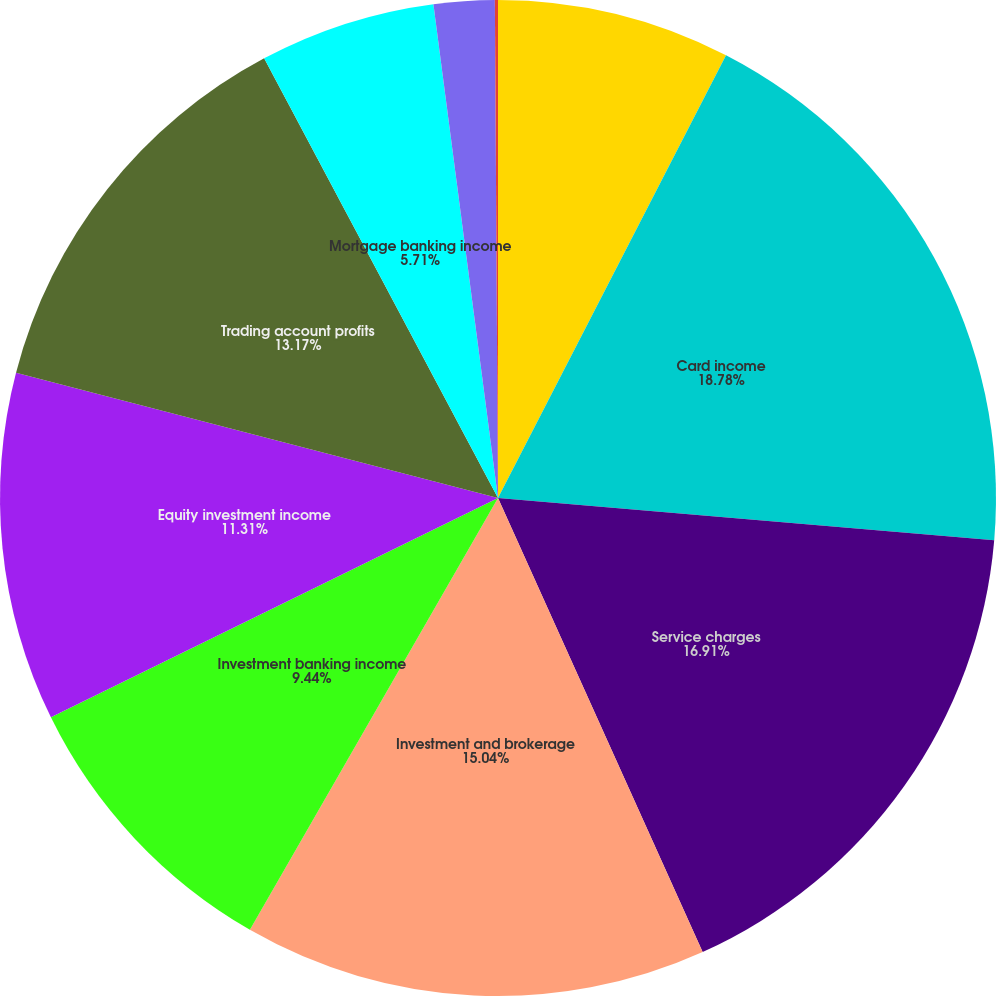Convert chart to OTSL. <chart><loc_0><loc_0><loc_500><loc_500><pie_chart><fcel>(Dollars in millions)<fcel>Card income<fcel>Service charges<fcel>Investment and brokerage<fcel>Investment banking income<fcel>Equity investment income<fcel>Trading account profits<fcel>Mortgage banking income<fcel>Insurance premiums<fcel>Gains on sales of debt<nl><fcel>7.57%<fcel>18.78%<fcel>16.91%<fcel>15.04%<fcel>9.44%<fcel>11.31%<fcel>13.17%<fcel>5.71%<fcel>1.97%<fcel>0.1%<nl></chart> 